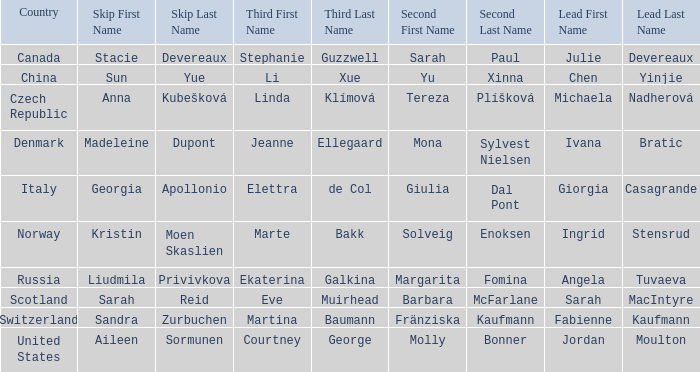What skip has angela tuvaeva as the lead? Liudmila Privivkova. 